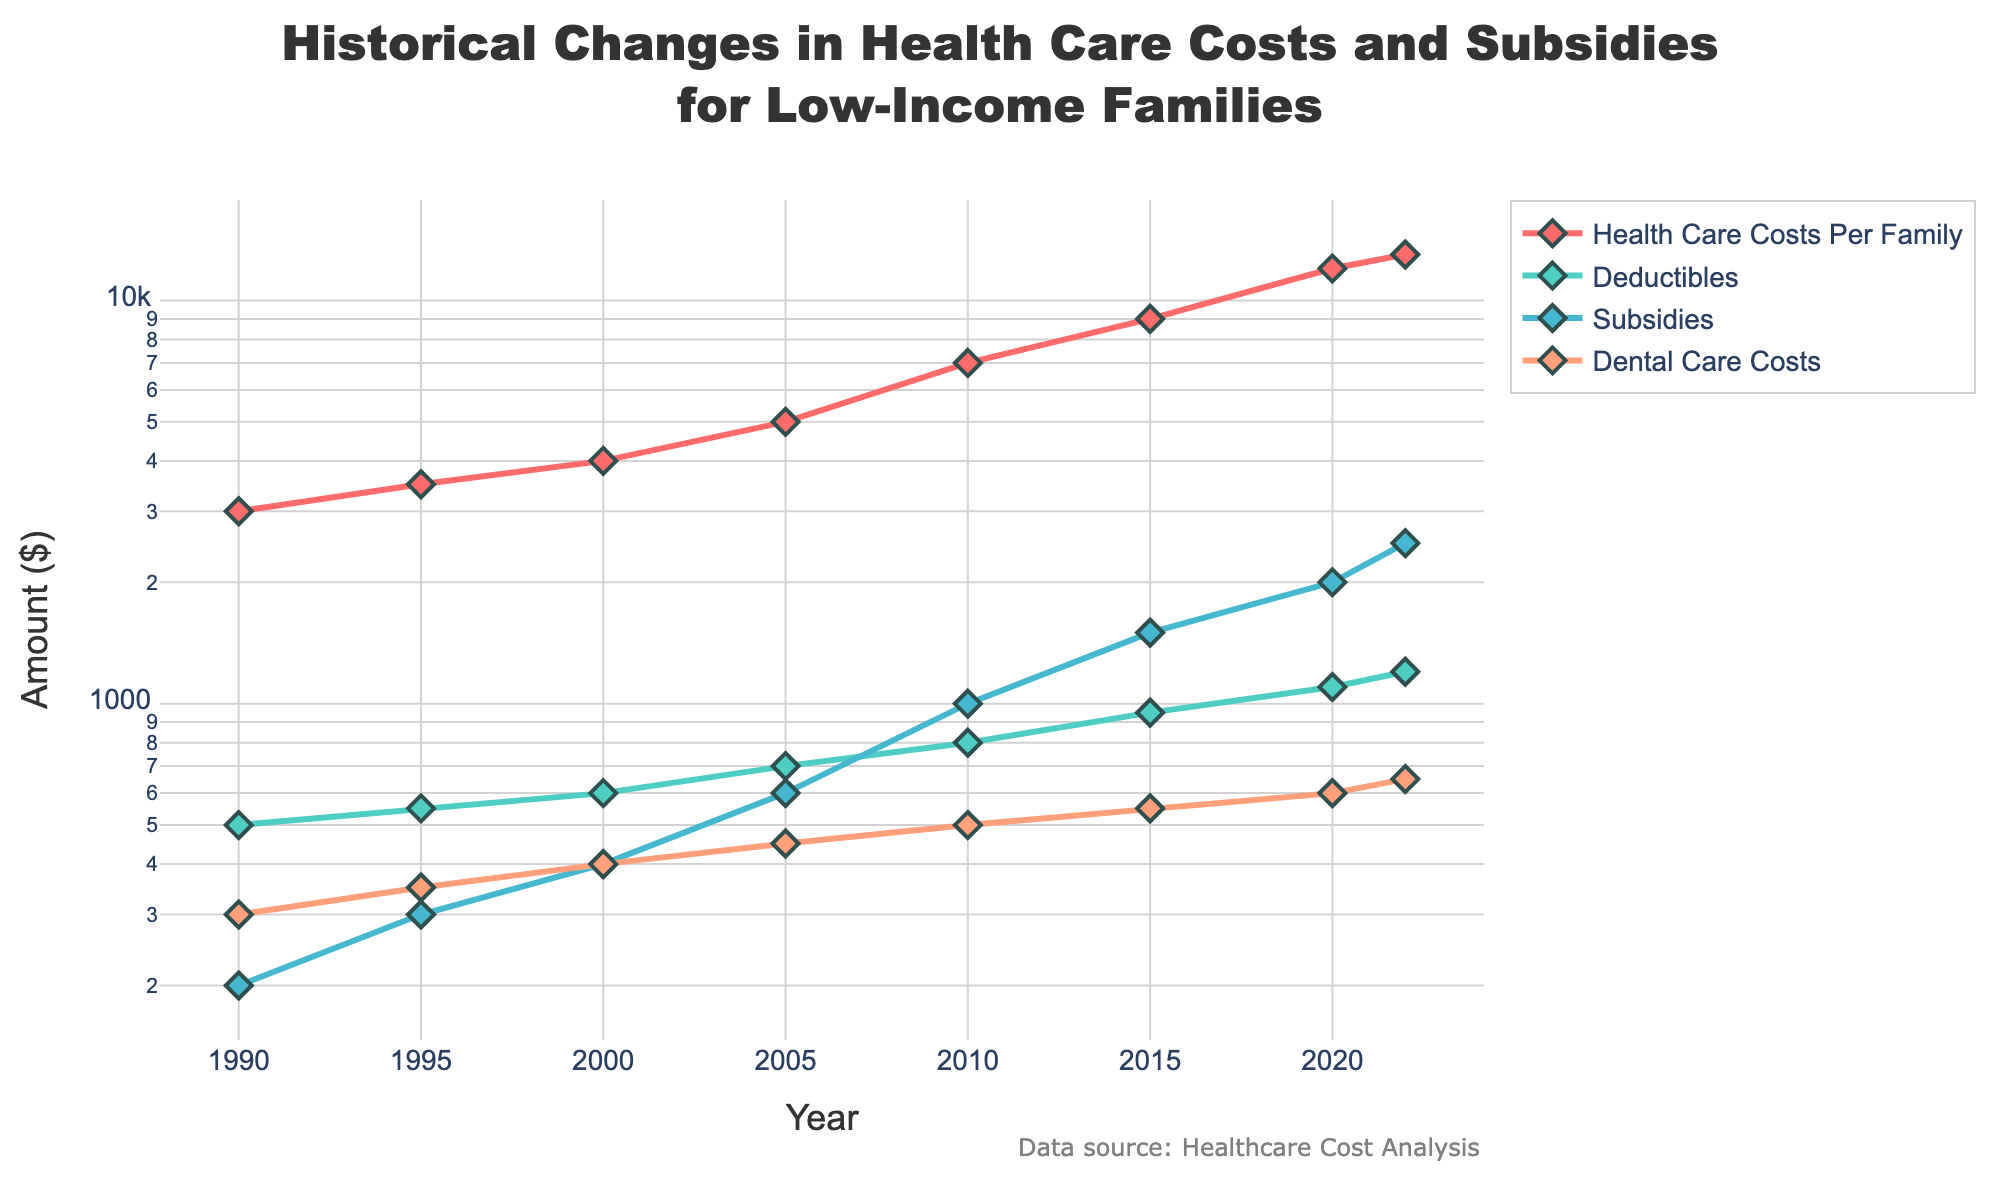What is the title of the plot? The title of the plot is displayed prominently at the top.
Answer: Historical Changes in Health Care Costs and Subsidies for Low-Income Families Which metric has the highest cost in 2022? From the plot, you can observe that "Health Care Costs Per Family" has the highest value at the rightmost point representing 2022.
Answer: Health Care Costs Per Family How has the "Subsidies" trend changed over time? The line representing "Subsidies" shows a steady increase from 1990 to 2022 when looked at the x-axis (Year) and the corresponding y-axis values.
Answer: Steadily increased Which two metrics show a similar upward trend from 1990 to 2022? By observing the general direction of the lines, both "Health Care Costs Per Family" and "Subsidies" exhibit a similar pattern of upward movement.
Answer: Health Care Costs Per Family and Subsidies What was the approximate deductible amount in the year 2000? Locate the "Deductibles" line plot and find the data point corresponding to the year 2000 on the x-axis.
Answer: 600 By how much did the "Dental Care Costs" increase from 1990 to 2022? Subtract the value of "Dental Care Costs" in 1990 from the value in 2022. (650 - 300 = 350)
Answer: 350 Which metric shows the smallest change over the years? By comparing the overall change in value for each line, "Dental Care Costs" exhibits the smallest change from 1990 to 2022.
Answer: Dental Care Costs In which year did "Health Care Costs Per Family" reach $7000? Find the point where the "Health Care Costs Per Family" line crosses the $7000 mark on the y-axis and trace it to the x-axis to determine the year.
Answer: 2010 What is the difference between "Health Care Costs Per Family" and "Subsidies" in 2022? Find the values of "Health Care Costs Per Family" and "Subsidies" in 2022 and subtract the value of "Subsidies" from "Health Care Costs Per Family". (13000 - 2500 = 10500)
Answer: 10500 